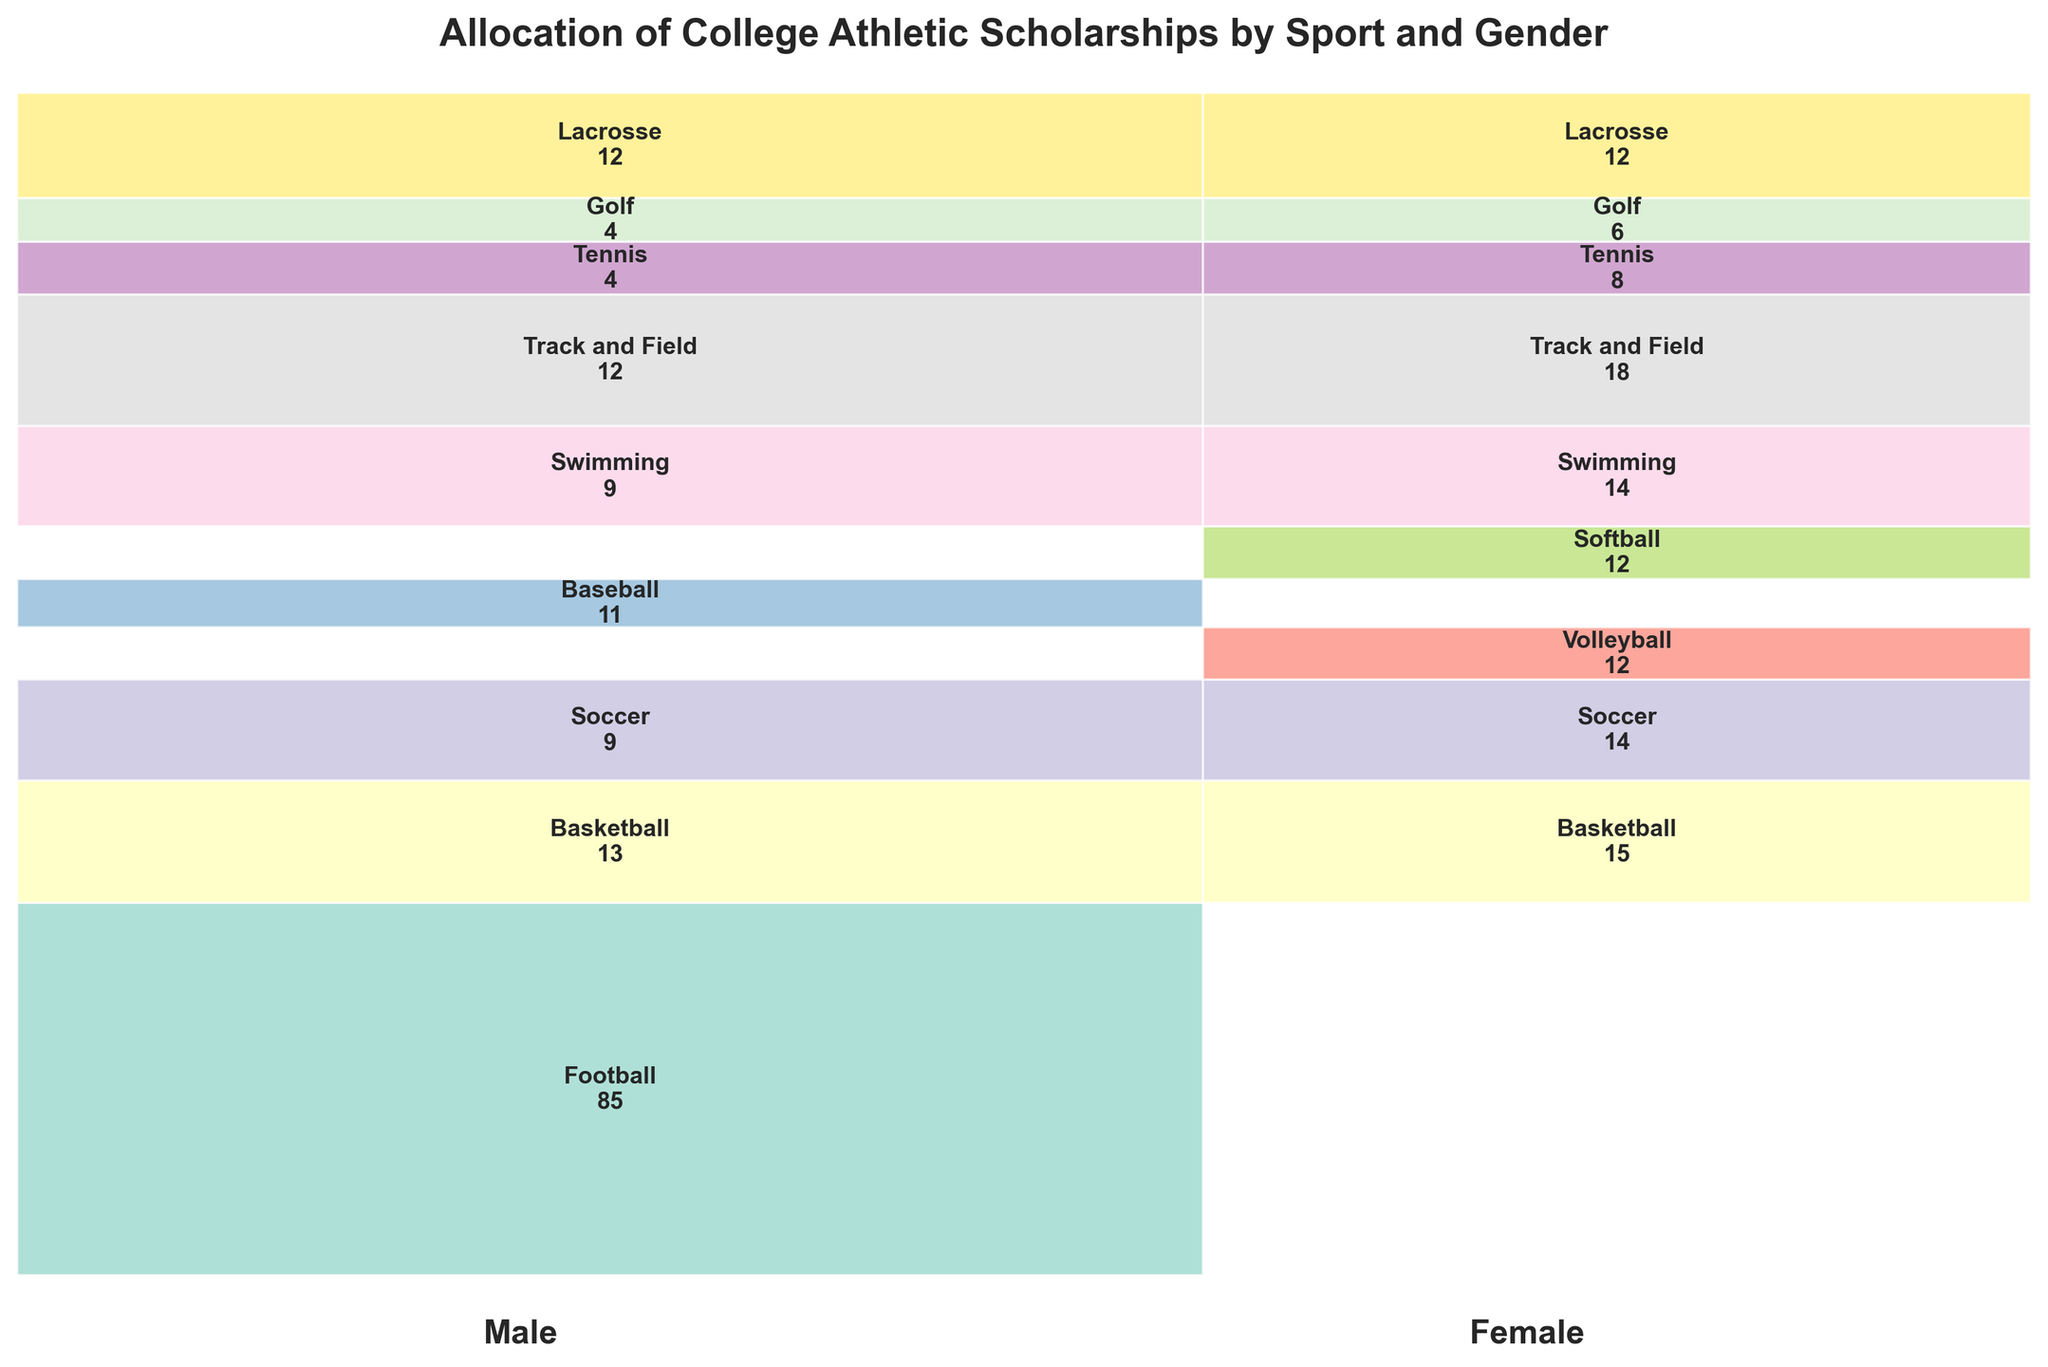what is the title of the plot? The title of the plot is written at the top center of the figure in a larger, bold font, which is a common convention for titling graphs
Answer: Allocation of College Athletic Scholarships by Sport and Gender how many scholarships are allocated to male basketball players? The number of scholarships allocated to male basketball players is indicated within the mosaic plot where the label 'Basketball' appears under the 'Male' section
Answer: 13 which sport receives more scholarships for females, Soccer or Volleyball? By comparing the heights of the rectangles labeled 'Soccer' and 'Volleyball' under the 'Female' section, we can see that the 'Soccer' rectangle is taller. Additionally, the numbers in the rectangles show 14 for Soccer and 12 for Volleyball
Answer: Soccer what is the total number of scholarships allocated to both male and female swimming athletes? To find the total number of swimming scholarships, sum the number of male and female swimming scholarships as seen in the respective rectangles: 9 (male) + 14 (female)
Answer: 23 does the sport of Tennis have more scholarships for male or female athletes? By comparing the size of the rectangles and the numbers within them under the sport of Tennis, we see that the 'Female' section has 8 scholarships while the 'Male' section has 4
Answer: Female are there any sports with an equal number of scholarships allocated to both genders? By visually inspecting the mosaic plot, we notice that Lacrosse has identical rectangles for both genders with the same number of scholarships indicated within them
Answer: Lacrosse which gender receives more total scholarships for Track and Field? The comparison of the rectangles under the sport 'Track and Field' shows that the female section is taller and has more scholarships (18 for females versus 12 for males)
Answer: Female do male or female athletes receive more scholarships in Golf? Looking at the mosaic plot, the 'Female' rectangle under Golf has a larger number (6) compared to the 'Male' rectangle (4), indicating females receive more scholarships in this sport
Answer: Female which sport has the highest single-gender scholarship allocation, and what is the value? The figure shows that Football (under 'Male') has the tallest and widest rectangle labeled '85,' indicating the highest single-gender scholarship allocation
Answer: Football, 85 is the distribution of scholarships roughly equal between genders? To determine this, we need to compare the sum of scholarships in the 'Male' and 'Female' sections. However, visual inspection already shows a clear imbalance with Football receiving a significant portion of the total scholarships for males
Answer: No 